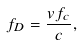<formula> <loc_0><loc_0><loc_500><loc_500>f _ { D } = \frac { v f _ { c } } { c } ,</formula> 